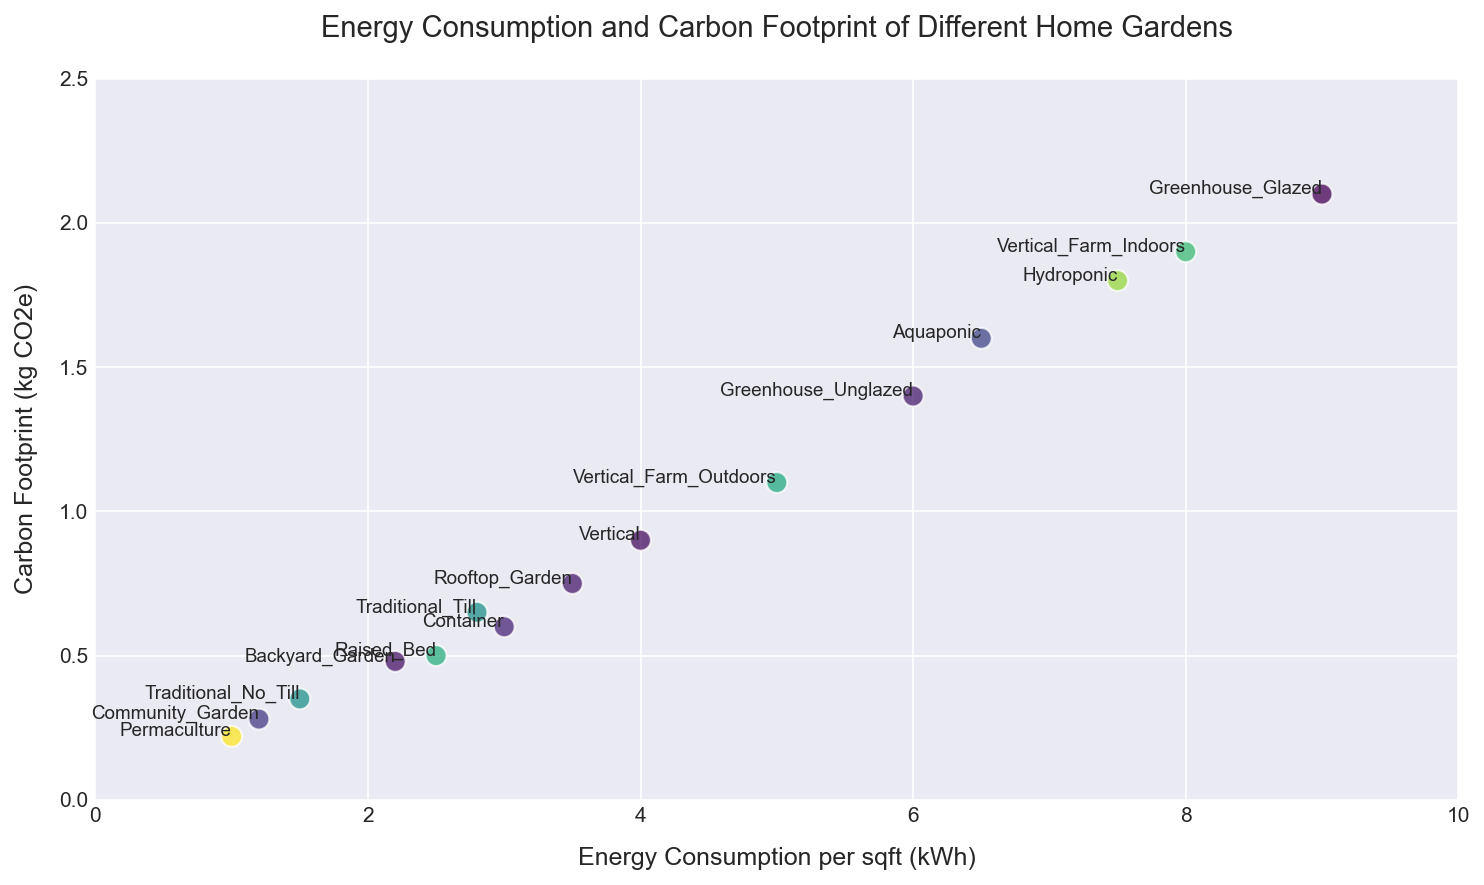How does the energy consumption of a hydroponic garden compare to a raised bed garden? To compare the energy consumption, look at the x-axis values for Hydroponic and Raised_Bed. Hydroponic has an energy consumption of 7.5 kWh per sqft, while Raised_Bed has 2.5 kWh per sqft. Therefore, Hydroponic consumes more energy.
Answer: Hydroponic consumes 5 kWh per sqft more than Raised_Bed Which garden type has the lowest carbon footprint and what is its value? To identify the garden with the lowest carbon footprint, check the y-axis values. Permaculture has the lowest carbon footprint at 0.22 kg CO2e.
Answer: Permaculture, 0.22 kg CO2e What is the sum of the carbon footprints of the two types of greenhouses? Add the carbon footprints of Greenhouse_Glazed and Greenhouse_Unglazed. Glazed has 2.1 kg CO2e and Unglazed has 1.4 kg CO2e. 2.1 + 1.4 = 3.5 kg CO2e.
Answer: 3.5 kg CO2e Which garden type occupies the highest position on the y-axis (i.e., has the highest carbon footprint)? Look for the data point highest on the y-axis. Greenhouse_Glazed is the highest with a carbon footprint of 2.1 kg CO2e.
Answer: Greenhouse_Glazed What is the difference in energy consumption between Vertical Farm Indoors and Vertical Farm Outdoors? Subtract the x-axis value of Vertical Farm Outdoors from Vertical Farm Indoors. Indoors is at 8.0 kWh and Outdoors is at 5.0 kWh. 8.0 - 5.0 = 3.0 kWh.
Answer: 3.0 kWh How many garden types have an energy consumption of 5 kWh per sqft or more and what are they? Count the garden types whose x-axis values are 5 kWh or more: Hydroponic (7.5), Aquaponic (6.5), Greenhouse_Glazed (9.0), Greenhouse_Unglazed (6.0), Vertical_Farm_Indoors (8.0), Vertical_Farm_Outdoors (5.0). There are 6 garden types.
Answer: 6: Hydroponic, Aquaponic, Greenhouse_Glazed, Greenhouse_Unglazed, Vertical_Farm_Indoors, Vertical_Farm_Outdoors Which garden type is closest to the origin (0,0) on the plot? Identify the data point closest to the (0,0) origin by looking for the smallest combined values on both axes. Community_Garden is closest with 1.2 kWh and 0.28 kg CO2e.
Answer: Community_Garden What's the average carbon footprint of all garden types that have an energy consumption below 3 kWh per sqft? Identify and average the carbon footprints of garden types with x-axis values <3. Traditional_No_Till (0.35), Community_Garden (0.28), Backyard_Garden (0.48), and Permaculture (0.22). Average: (0.35 + 0.28 + 0.48 + 0.22) / 4 = 0.3325 kg CO2e.
Answer: 0.3325 kg CO2e 